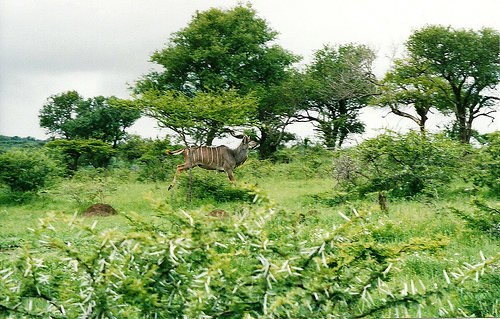<image>
Is the sky behind the deer? Yes. From this viewpoint, the sky is positioned behind the deer, with the deer partially or fully occluding the sky. 